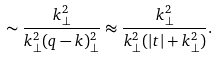Convert formula to latex. <formula><loc_0><loc_0><loc_500><loc_500>\sim \frac { k ^ { 2 } _ { \perp } } { k ^ { 2 } _ { \perp } ( q - k ) ^ { 2 } _ { \perp } } \approx \frac { k ^ { 2 } _ { \perp } } { k ^ { 2 } _ { \perp } ( | t | + k ^ { 2 } _ { \perp } ) } .</formula> 